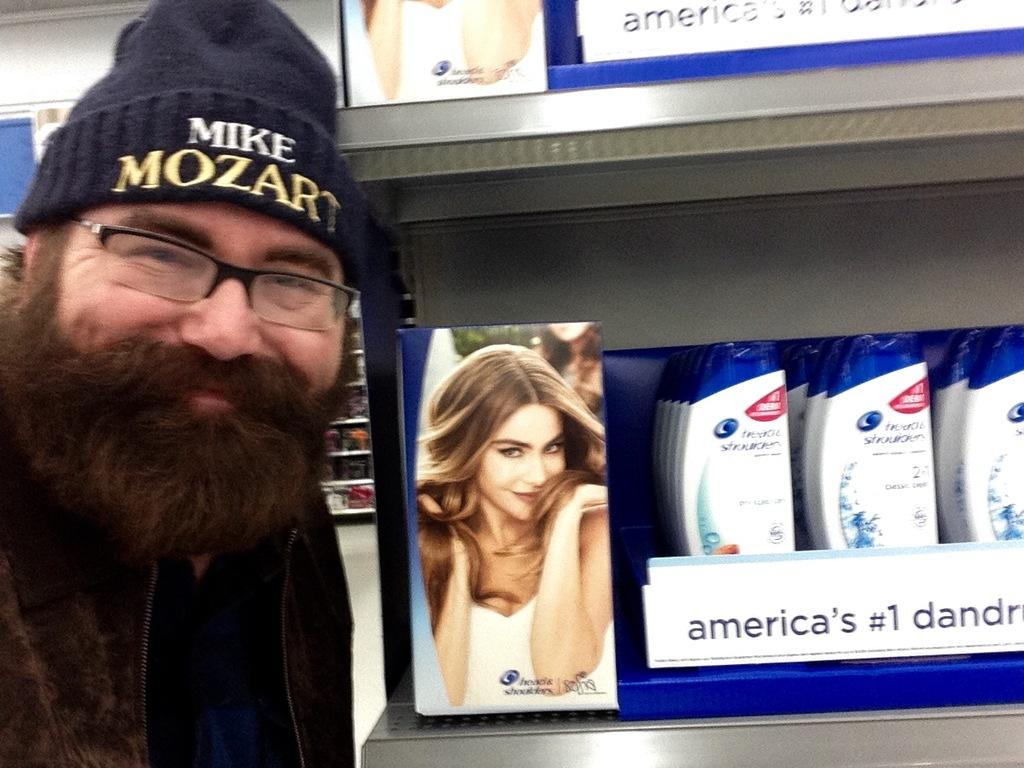Who or what is on the left side of the image? There is a person on the left side of the image. What can be seen in the image besides the person? There is a rack in the image, and shampoos are on the rack. Is there any other visual element in the image? Yes, there is a photo in the image. What can be seen in the background of the image? There are racks visible in the background of the image. What arithmetic problem can be solved using the shampoos on the rack? There is no arithmetic problem present in the image, as it only features a person, a rack with shampoos, a photo, and racks visible in the background. 